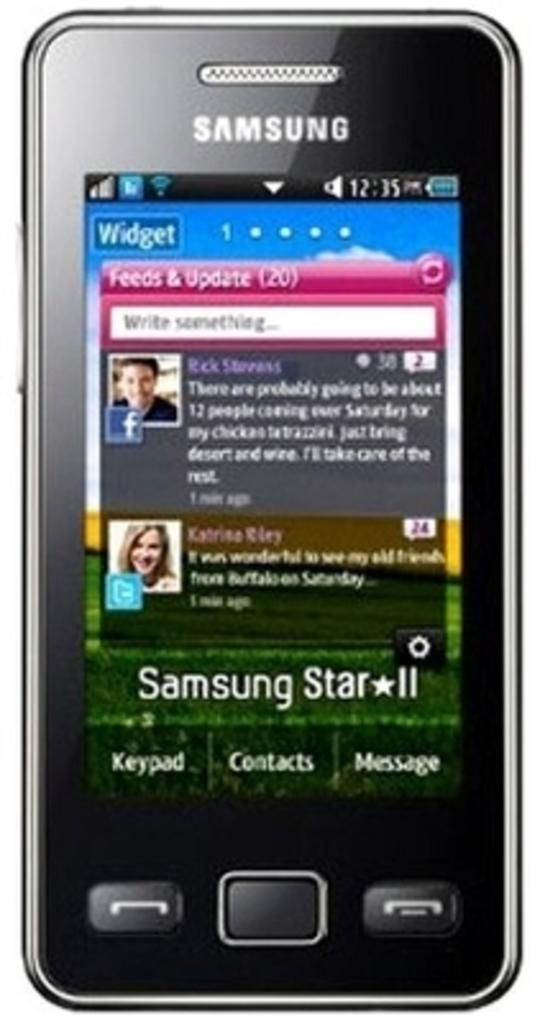<image>
Give a short and clear explanation of the subsequent image. A Samsung phone shows a widget on the screen. 